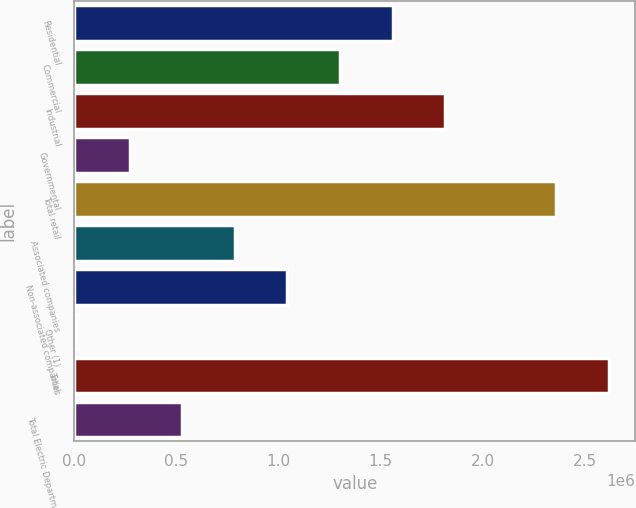Convert chart to OTSL. <chart><loc_0><loc_0><loc_500><loc_500><bar_chart><fcel>Residential<fcel>Commercial<fcel>Industrial<fcel>Governmental<fcel>Total retail<fcel>Associated companies<fcel>Non-associated companies<fcel>Other (1)<fcel>Total<fcel>Total Electric Department<nl><fcel>1.55959e+06<fcel>1.30178e+06<fcel>1.8174e+06<fcel>270538<fcel>2.35906e+06<fcel>786160<fcel>1.04397e+06<fcel>12727<fcel>2.61687e+06<fcel>528349<nl></chart> 